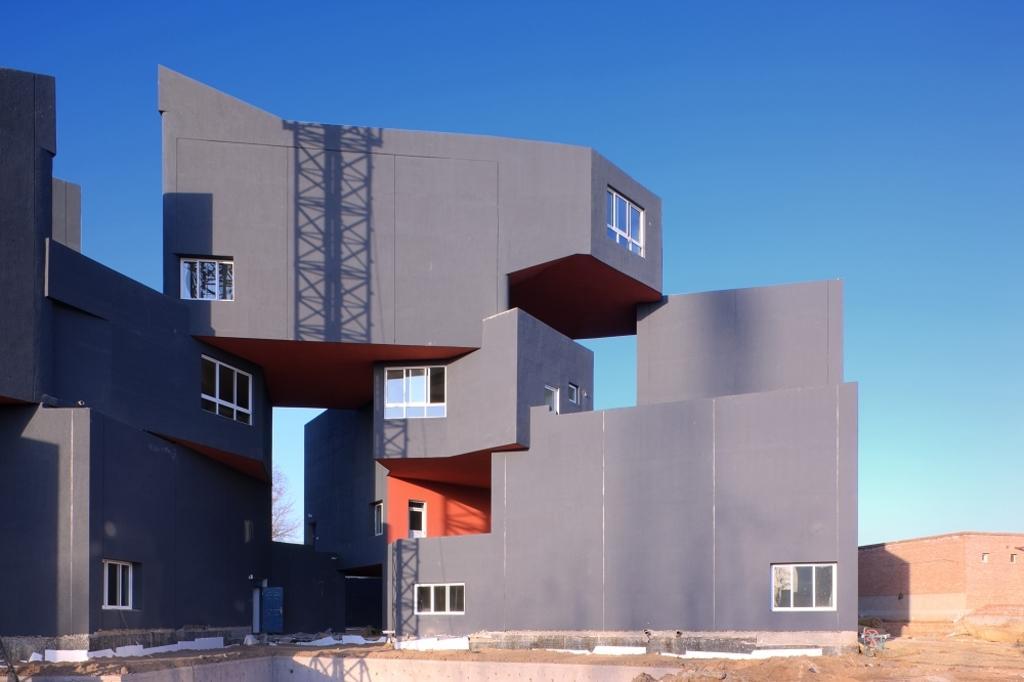Please provide a concise description of this image. The picture consists of a building painted grey. The picture consists of windows to the building. On the right there is a small house with brick wall. In the foreground there is sand. Sky is clear and it is sunny. 